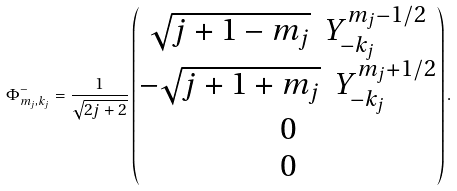Convert formula to latex. <formula><loc_0><loc_0><loc_500><loc_500>\Phi ^ { - } _ { m _ { j } , k _ { j } } = \frac { 1 } { \sqrt { 2 j + 2 } } \begin{pmatrix} \sqrt { j + 1 - m _ { j } } \ \ Y ^ { m _ { j } - 1 / 2 } _ { - k _ { j } } \\ - \sqrt { j + 1 + m _ { j } } \ \ Y ^ { m _ { j } + 1 / 2 } _ { - k _ { j } } \\ 0 \\ 0 \end{pmatrix} .</formula> 